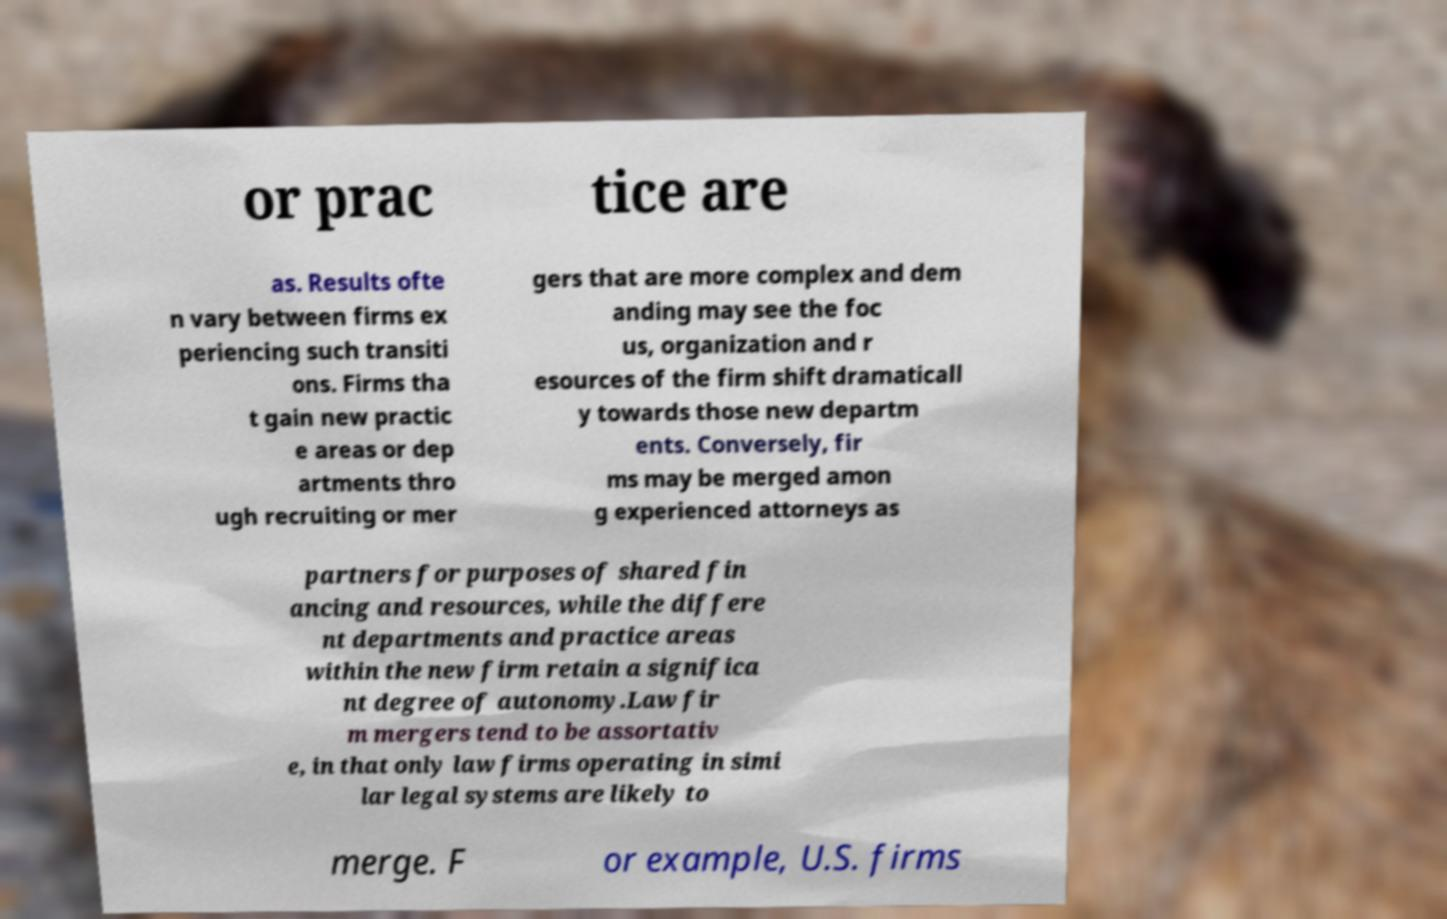There's text embedded in this image that I need extracted. Can you transcribe it verbatim? or prac tice are as. Results ofte n vary between firms ex periencing such transiti ons. Firms tha t gain new practic e areas or dep artments thro ugh recruiting or mer gers that are more complex and dem anding may see the foc us, organization and r esources of the firm shift dramaticall y towards those new departm ents. Conversely, fir ms may be merged amon g experienced attorneys as partners for purposes of shared fin ancing and resources, while the differe nt departments and practice areas within the new firm retain a significa nt degree of autonomy.Law fir m mergers tend to be assortativ e, in that only law firms operating in simi lar legal systems are likely to merge. F or example, U.S. firms 